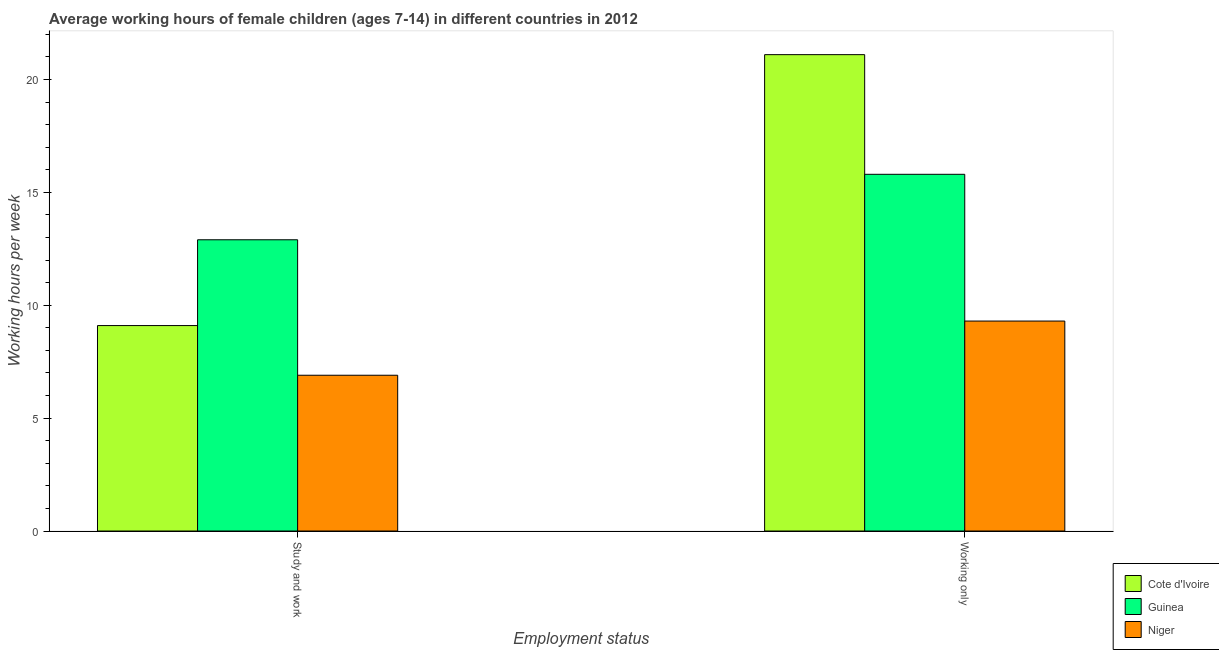How many different coloured bars are there?
Ensure brevity in your answer.  3. How many groups of bars are there?
Your answer should be compact. 2. Are the number of bars per tick equal to the number of legend labels?
Make the answer very short. Yes. How many bars are there on the 2nd tick from the left?
Offer a terse response. 3. How many bars are there on the 2nd tick from the right?
Offer a terse response. 3. What is the label of the 1st group of bars from the left?
Your response must be concise. Study and work. What is the average working hour of children involved in only work in Niger?
Your answer should be compact. 9.3. Across all countries, what is the maximum average working hour of children involved in only work?
Your answer should be very brief. 21.1. In which country was the average working hour of children involved in only work maximum?
Provide a succinct answer. Cote d'Ivoire. In which country was the average working hour of children involved in study and work minimum?
Your answer should be very brief. Niger. What is the total average working hour of children involved in study and work in the graph?
Provide a short and direct response. 28.9. What is the difference between the average working hour of children involved in only work in Cote d'Ivoire and that in Guinea?
Keep it short and to the point. 5.3. What is the average average working hour of children involved in study and work per country?
Your answer should be compact. 9.63. What is the difference between the average working hour of children involved in study and work and average working hour of children involved in only work in Niger?
Offer a terse response. -2.4. What is the ratio of the average working hour of children involved in study and work in Guinea to that in Cote d'Ivoire?
Provide a short and direct response. 1.42. What does the 1st bar from the left in Study and work represents?
Give a very brief answer. Cote d'Ivoire. What does the 1st bar from the right in Study and work represents?
Provide a succinct answer. Niger. How many bars are there?
Make the answer very short. 6. Are all the bars in the graph horizontal?
Give a very brief answer. No. How many countries are there in the graph?
Offer a very short reply. 3. What is the difference between two consecutive major ticks on the Y-axis?
Make the answer very short. 5. Are the values on the major ticks of Y-axis written in scientific E-notation?
Your answer should be compact. No. Does the graph contain grids?
Provide a short and direct response. No. What is the title of the graph?
Make the answer very short. Average working hours of female children (ages 7-14) in different countries in 2012. What is the label or title of the X-axis?
Provide a short and direct response. Employment status. What is the label or title of the Y-axis?
Provide a succinct answer. Working hours per week. What is the Working hours per week in Niger in Study and work?
Your response must be concise. 6.9. What is the Working hours per week in Cote d'Ivoire in Working only?
Give a very brief answer. 21.1. Across all Employment status, what is the maximum Working hours per week of Cote d'Ivoire?
Your answer should be very brief. 21.1. Across all Employment status, what is the maximum Working hours per week of Niger?
Make the answer very short. 9.3. Across all Employment status, what is the minimum Working hours per week in Cote d'Ivoire?
Offer a very short reply. 9.1. Across all Employment status, what is the minimum Working hours per week of Guinea?
Ensure brevity in your answer.  12.9. What is the total Working hours per week in Cote d'Ivoire in the graph?
Provide a succinct answer. 30.2. What is the total Working hours per week of Guinea in the graph?
Give a very brief answer. 28.7. What is the difference between the Working hours per week of Guinea in Study and work and that in Working only?
Your response must be concise. -2.9. What is the difference between the Working hours per week in Cote d'Ivoire in Study and work and the Working hours per week in Guinea in Working only?
Give a very brief answer. -6.7. What is the difference between the Working hours per week in Cote d'Ivoire in Study and work and the Working hours per week in Niger in Working only?
Keep it short and to the point. -0.2. What is the average Working hours per week in Guinea per Employment status?
Ensure brevity in your answer.  14.35. What is the difference between the Working hours per week in Cote d'Ivoire and Working hours per week in Guinea in Study and work?
Provide a short and direct response. -3.8. What is the difference between the Working hours per week in Cote d'Ivoire and Working hours per week in Niger in Study and work?
Provide a short and direct response. 2.2. What is the difference between the Working hours per week in Guinea and Working hours per week in Niger in Study and work?
Provide a succinct answer. 6. What is the difference between the Working hours per week of Cote d'Ivoire and Working hours per week of Niger in Working only?
Your answer should be very brief. 11.8. What is the ratio of the Working hours per week in Cote d'Ivoire in Study and work to that in Working only?
Ensure brevity in your answer.  0.43. What is the ratio of the Working hours per week of Guinea in Study and work to that in Working only?
Offer a very short reply. 0.82. What is the ratio of the Working hours per week of Niger in Study and work to that in Working only?
Make the answer very short. 0.74. What is the difference between the highest and the second highest Working hours per week of Cote d'Ivoire?
Give a very brief answer. 12. What is the difference between the highest and the second highest Working hours per week in Niger?
Your response must be concise. 2.4. What is the difference between the highest and the lowest Working hours per week in Cote d'Ivoire?
Your response must be concise. 12. What is the difference between the highest and the lowest Working hours per week of Guinea?
Keep it short and to the point. 2.9. 